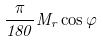<formula> <loc_0><loc_0><loc_500><loc_500>\frac { \pi } { 1 8 0 } M _ { r } \cos \varphi</formula> 